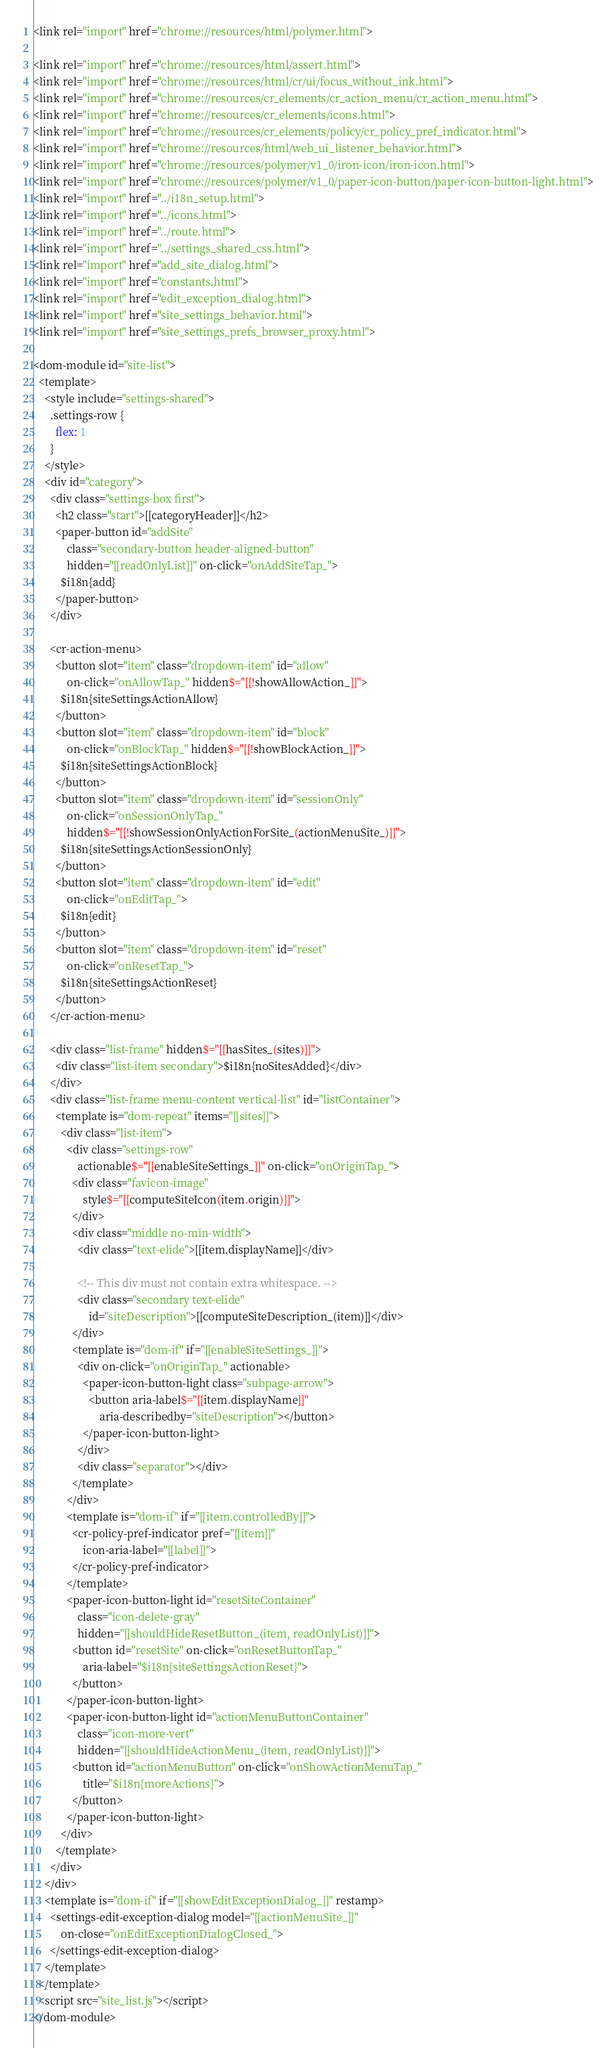<code> <loc_0><loc_0><loc_500><loc_500><_HTML_><link rel="import" href="chrome://resources/html/polymer.html">

<link rel="import" href="chrome://resources/html/assert.html">
<link rel="import" href="chrome://resources/html/cr/ui/focus_without_ink.html">
<link rel="import" href="chrome://resources/cr_elements/cr_action_menu/cr_action_menu.html">
<link rel="import" href="chrome://resources/cr_elements/icons.html">
<link rel="import" href="chrome://resources/cr_elements/policy/cr_policy_pref_indicator.html">
<link rel="import" href="chrome://resources/html/web_ui_listener_behavior.html">
<link rel="import" href="chrome://resources/polymer/v1_0/iron-icon/iron-icon.html">
<link rel="import" href="chrome://resources/polymer/v1_0/paper-icon-button/paper-icon-button-light.html">
<link rel="import" href="../i18n_setup.html">
<link rel="import" href="../icons.html">
<link rel="import" href="../route.html">
<link rel="import" href="../settings_shared_css.html">
<link rel="import" href="add_site_dialog.html">
<link rel="import" href="constants.html">
<link rel="import" href="edit_exception_dialog.html">
<link rel="import" href="site_settings_behavior.html">
<link rel="import" href="site_settings_prefs_browser_proxy.html">

<dom-module id="site-list">
  <template>
    <style include="settings-shared">
      .settings-row {
        flex: 1
      }
    </style>
    <div id="category">
      <div class="settings-box first">
        <h2 class="start">[[categoryHeader]]</h2>
        <paper-button id="addSite"
            class="secondary-button header-aligned-button"
            hidden="[[readOnlyList]]" on-click="onAddSiteTap_">
          $i18n{add}
        </paper-button>
      </div>

      <cr-action-menu>
        <button slot="item" class="dropdown-item" id="allow"
            on-click="onAllowTap_" hidden$="[[!showAllowAction_]]">
          $i18n{siteSettingsActionAllow}
        </button>
        <button slot="item" class="dropdown-item" id="block"
            on-click="onBlockTap_" hidden$="[[!showBlockAction_]]">
          $i18n{siteSettingsActionBlock}
        </button>
        <button slot="item" class="dropdown-item" id="sessionOnly"
            on-click="onSessionOnlyTap_"
            hidden$="[[!showSessionOnlyActionForSite_(actionMenuSite_)]]">
          $i18n{siteSettingsActionSessionOnly}
        </button>
        <button slot="item" class="dropdown-item" id="edit"
            on-click="onEditTap_">
          $i18n{edit}
        </button>
        <button slot="item" class="dropdown-item" id="reset"
            on-click="onResetTap_">
          $i18n{siteSettingsActionReset}
        </button>
      </cr-action-menu>

      <div class="list-frame" hidden$="[[hasSites_(sites)]]">
        <div class="list-item secondary">$i18n{noSitesAdded}</div>
      </div>
      <div class="list-frame menu-content vertical-list" id="listContainer">
        <template is="dom-repeat" items="[[sites]]">
          <div class="list-item">
            <div class="settings-row"
                actionable$="[[enableSiteSettings_]]" on-click="onOriginTap_">
              <div class="favicon-image"
                  style$="[[computeSiteIcon(item.origin)]]">
              </div>
              <div class="middle no-min-width">
                <div class="text-elide">[[item.displayName]]</div>

                <!-- This div must not contain extra whitespace. -->
                <div class="secondary text-elide"
                    id="siteDescription">[[computeSiteDescription_(item)]]</div>
              </div>
              <template is="dom-if" if="[[enableSiteSettings_]]">
                <div on-click="onOriginTap_" actionable>
                  <paper-icon-button-light class="subpage-arrow">
                    <button aria-label$="[[item.displayName]]"
                        aria-describedby="siteDescription"></button>
                  </paper-icon-button-light>
                </div>
                <div class="separator"></div>
              </template>
            </div>
            <template is="dom-if" if="[[item.controlledBy]]">
              <cr-policy-pref-indicator pref="[[item]]"
                  icon-aria-label="[[label]]">
              </cr-policy-pref-indicator>
            </template>
            <paper-icon-button-light id="resetSiteContainer"
                class="icon-delete-gray"
                hidden="[[shouldHideResetButton_(item, readOnlyList)]]">
              <button id="resetSite" on-click="onResetButtonTap_"
                  aria-label="$i18n{siteSettingsActionReset}">
              </button>
            </paper-icon-button-light>
            <paper-icon-button-light id="actionMenuButtonContainer"
                class="icon-more-vert"
                hidden="[[shouldHideActionMenu_(item, readOnlyList)]]">
              <button id="actionMenuButton" on-click="onShowActionMenuTap_"
                  title="$i18n{moreActions}">
              </button>
            </paper-icon-button-light>
          </div>
        </template>
      </div>
    </div>
    <template is="dom-if" if="[[showEditExceptionDialog_]]" restamp>
      <settings-edit-exception-dialog model="[[actionMenuSite_]]"
          on-close="onEditExceptionDialogClosed_">
      </settings-edit-exception-dialog>
    </template>
  </template>
  <script src="site_list.js"></script>
</dom-module>
</code> 